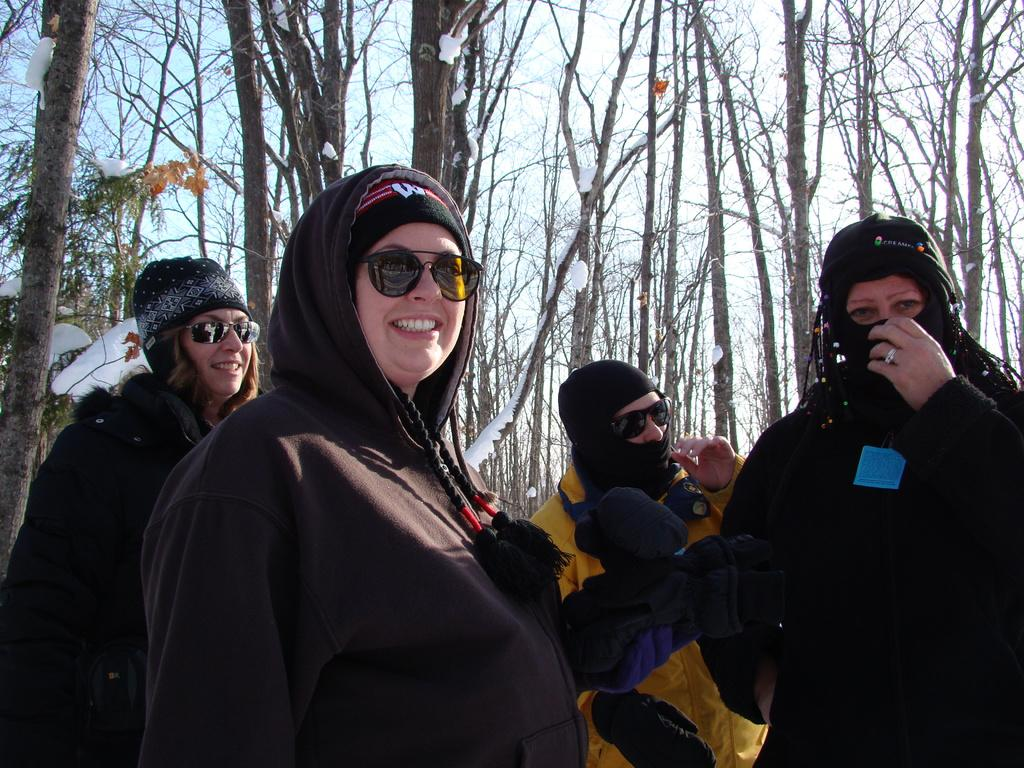What can be seen in the image? There are people standing in the image. What are the people wearing? The people are wearing jackets and caps. Are there any other objects worn by the people? Yes, there are other objects worn by the people. What can be seen in the background of the image? There are trees and the sky visible in the background of the image. What is the distance between the people and the bit in the image? There is no bit present in the image, so it is not possible to determine the distance between the people and a bit. 